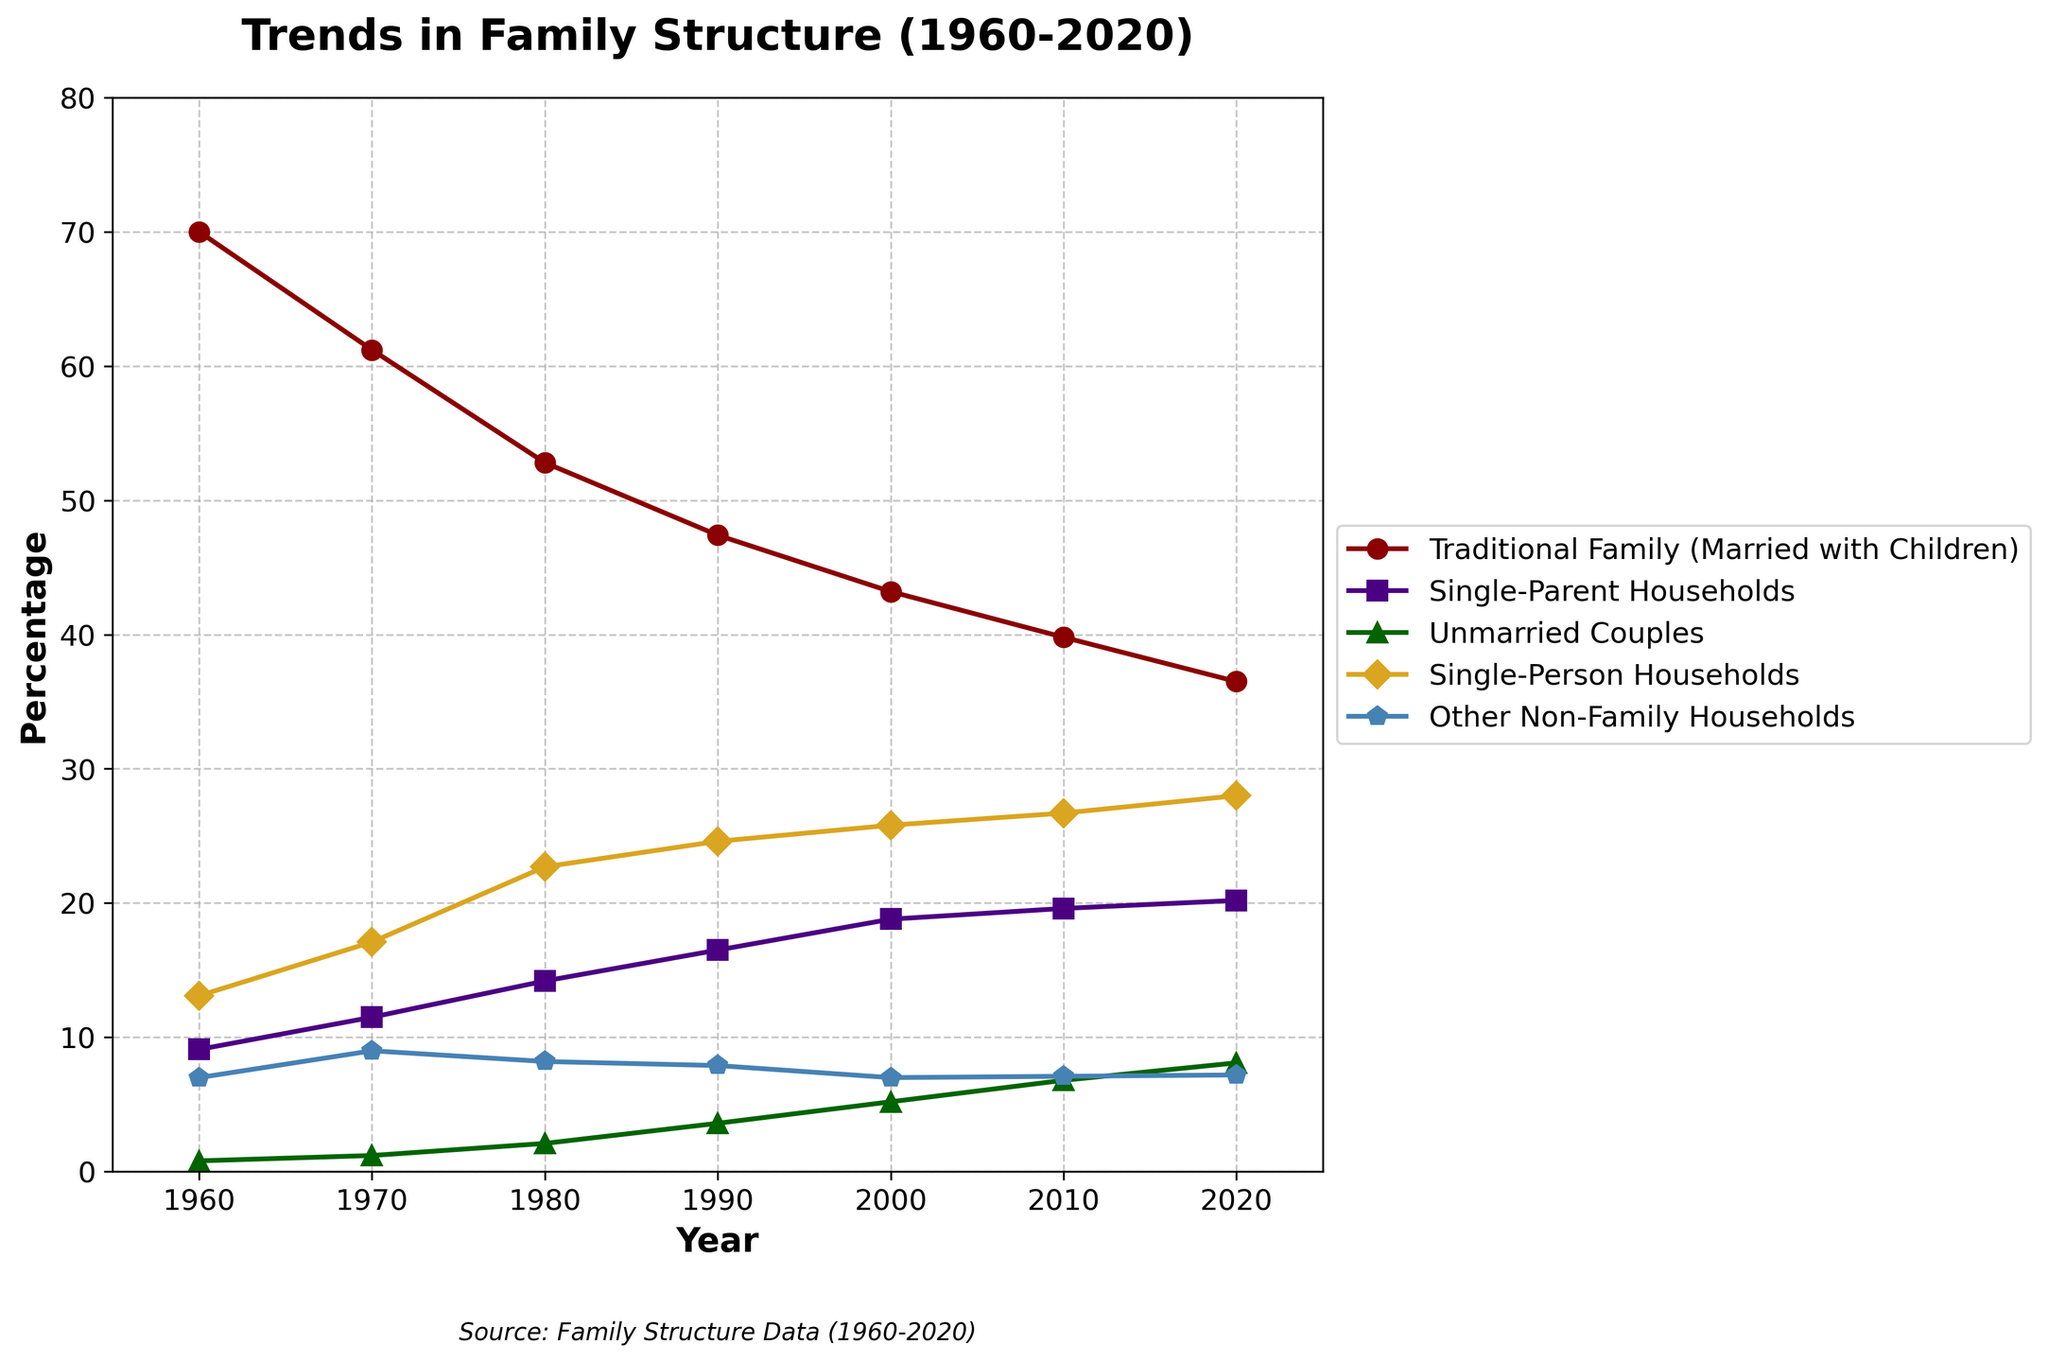What household type had the highest percentage in 1960? By examining the line chart, the "Traditional Family (Married with Children)" had the highest percentage in 1960, indicated by its position at the top of the graph in that year.
Answer: Traditional Family (Married with Children) Which household type has seen the most consistent increase from 1960 to 2020? Reviewing the trajectories of all lines from left to right (1960 to 2020), the "Single-Person Households" line shows a steady and consistent upward trend without any major drops.
Answer: Single-Person Households How much has the percentage of traditional families decreased from 1960 to 2020? The percentage of traditional families in 1960 was 70.0%. By 2020, this had decreased to 36.5%. The difference can be calculated as 70.0% - 36.5%.
Answer: 33.5% Between 1980 and 2000, which household type had the fastest growing rate? By observing the steepness of each line segment between 1980 and 2000, the "Unmarried Couples" line shows the steepest upward slope, indicating the fastest rate of growth during that period.
Answer: Unmarried Couples In which decade did single-parent households see the greatest increase in percentage? Looking at the plot for single-parent households, the greatest increase appears between 1970 and 1980, where the slope of the graph is steepest.
Answer: 1970-1980 What's the difference between the percentages of single-person households and traditional families in 2020? In 2020, the percentage of single-person households was 28.0%, and that of traditional families was 36.5%. The difference is calculated as 36.5% - 28.0%.
Answer: 8.5% Which household type had the second highest percentage in 1990? In 1990, the "Single-Person Households" shows the second highest position on the graph, just below traditional families but higher than all other household types.
Answer: Single-Person Households By how much did the percentage of unmarried couples increase from 1970 to 2020? The percentage of unmarried couples was 1.2% in 1970 and increased to 8.1% by 2020. The increase is calculated as 8.1% - 1.2%.
Answer: 6.9% Which household type remained relatively constant throughout the years 1960 to 2020? By inspecting the plotted lines, the line for "Other Non-Family Households" appears relatively flat, indicating minimal change and consistency over the years.
Answer: Other Non-Family Households 